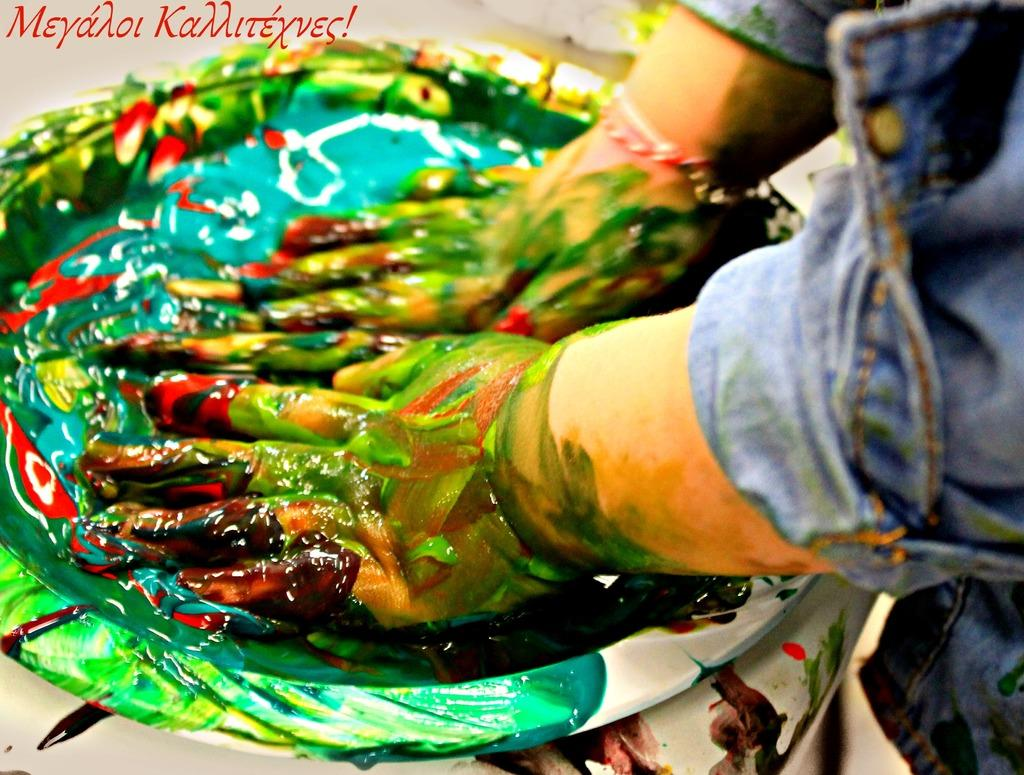What is present on the person's hand in the image? There is paint on the person's hand in the image. What else in the image is related to paint? There is a plate with paint in the image. Where is the plate with paint located? The plate with paint is placed on a surface in the image. What else can be seen in the image that is not related to paint? There is edited text in the image. Is there any smoke visible in the image? No, there is no smoke present in the image. Is there any dirt visible in the image? No, there is no dirt present in the image. 